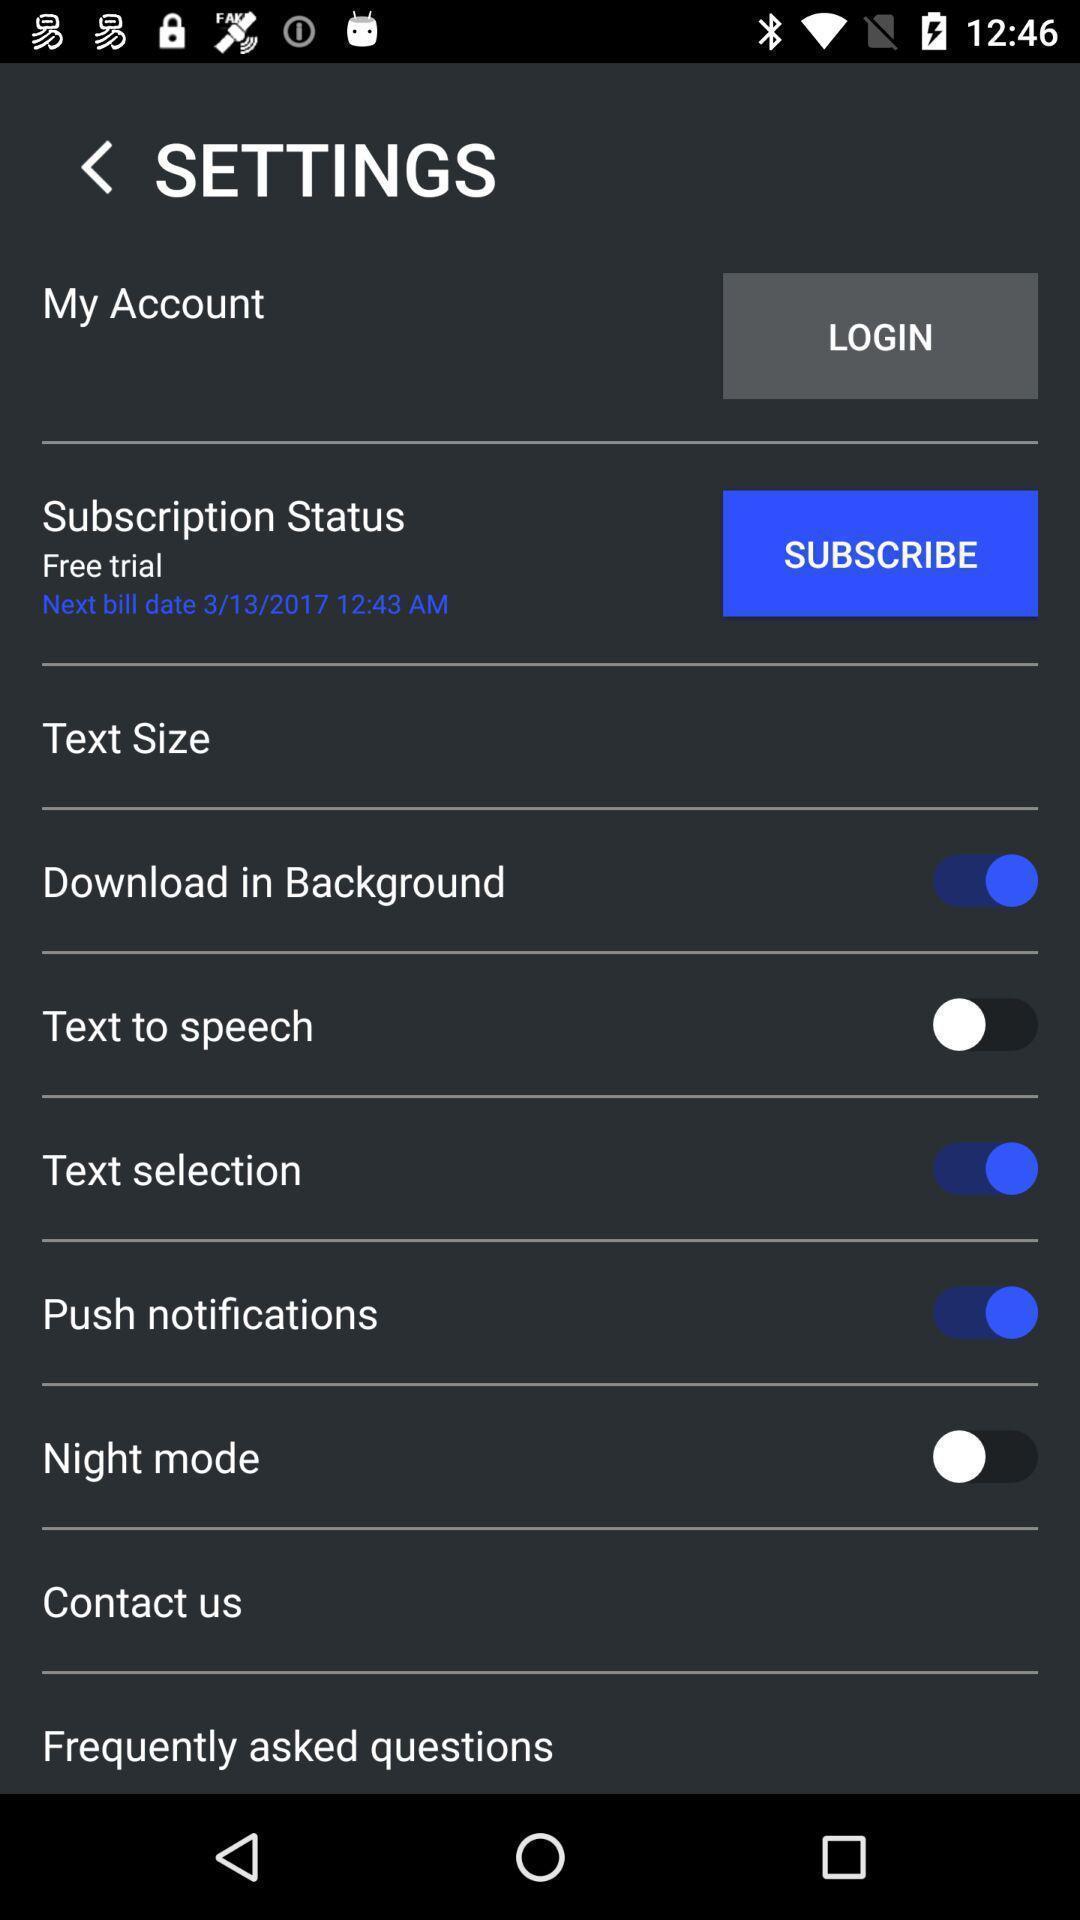Tell me about the visual elements in this screen capture. Settings page of a news application. 